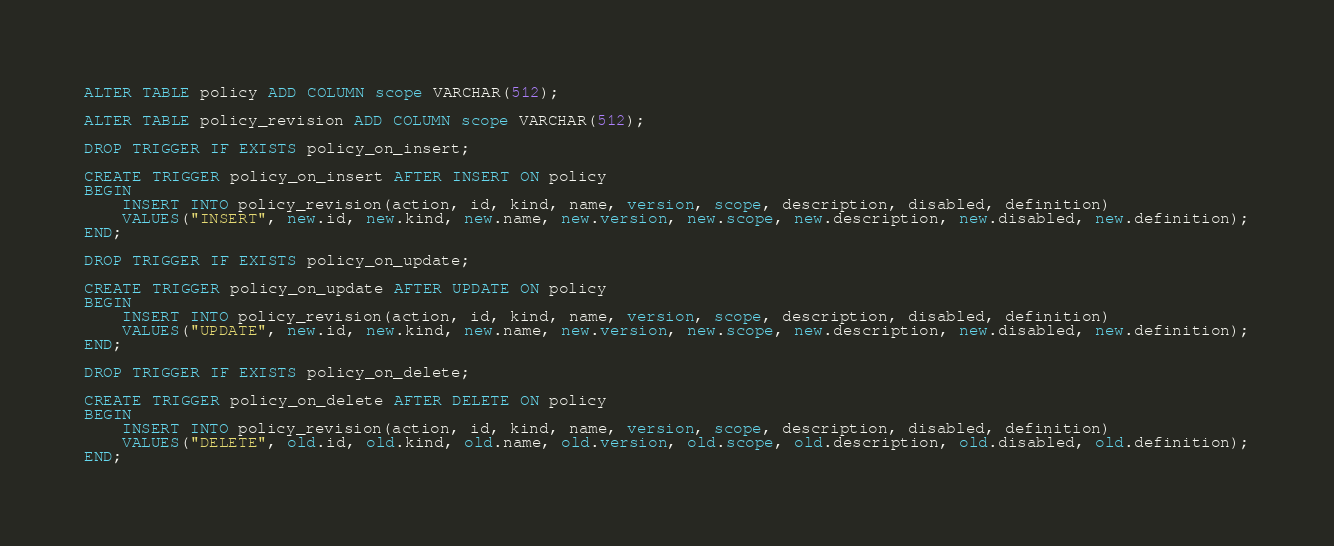Convert code to text. <code><loc_0><loc_0><loc_500><loc_500><_SQL_>
ALTER TABLE policy ADD COLUMN scope VARCHAR(512);  

ALTER TABLE policy_revision ADD COLUMN scope VARCHAR(512);  

DROP TRIGGER IF EXISTS policy_on_insert;

CREATE TRIGGER policy_on_insert AFTER INSERT ON policy 
BEGIN
    INSERT INTO policy_revision(action, id, kind, name, version, scope, description, disabled, definition)
    VALUES("INSERT", new.id, new.kind, new.name, new.version, new.scope, new.description, new.disabled, new.definition);
END;

DROP TRIGGER IF EXISTS policy_on_update;

CREATE TRIGGER policy_on_update AFTER UPDATE ON policy 
BEGIN
    INSERT INTO policy_revision(action, id, kind, name, version, scope, description, disabled, definition)
    VALUES("UPDATE", new.id, new.kind, new.name, new.version, new.scope, new.description, new.disabled, new.definition);
END;

DROP TRIGGER IF EXISTS policy_on_delete;

CREATE TRIGGER policy_on_delete AFTER DELETE ON policy 
BEGIN
    INSERT INTO policy_revision(action, id, kind, name, version, scope, description, disabled, definition)
    VALUES("DELETE", old.id, old.kind, old.name, old.version, old.scope, old.description, old.disabled, old.definition);
END;
</code> 